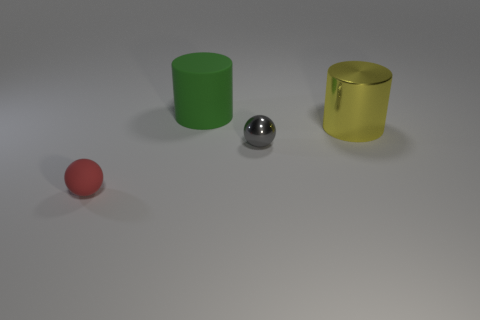Add 1 yellow cylinders. How many objects exist? 5 Subtract 0 blue balls. How many objects are left? 4 Subtract all red matte balls. Subtract all big metallic objects. How many objects are left? 2 Add 4 big cylinders. How many big cylinders are left? 6 Add 3 metallic things. How many metallic things exist? 5 